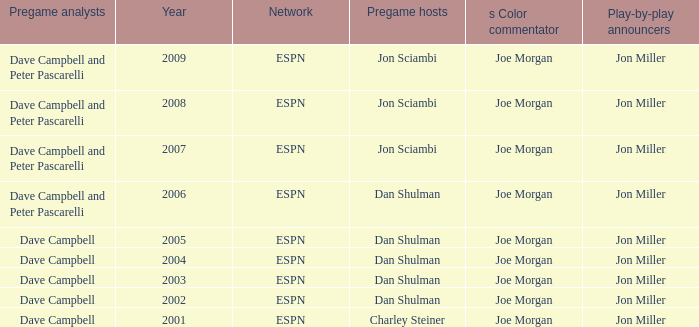Who is the pregame host when the pregame analysts is  Dave Campbell and the year is 2001? Charley Steiner. 